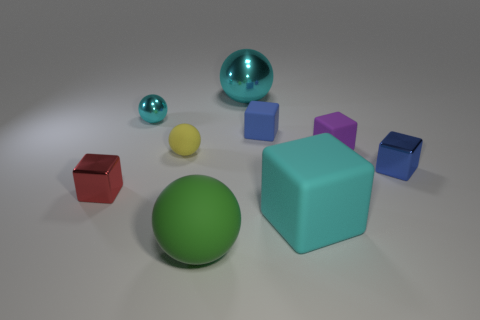What is the material of these objects? From the image, it's possible to infer that these objects have a smooth, matte finish, likely indicative of a plastic material. The two shiny spheres, however, have a reflective surface that may suggest they are made from a polished, metallic material. What could be the purpose of showing these objects together? These objects might be used as a study in geometry and color, possibly for an educational purpose or 3D rendering practice. They display basic geometric shapes and a range of colors, which could also serve as a visual aid in teaching about these concepts. 